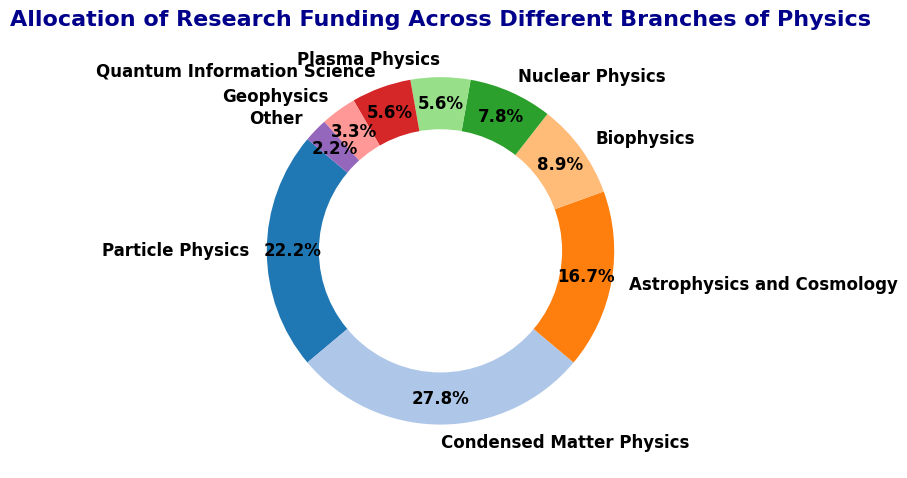Which branch of physics has the largest allocation of funding? Condensed Matter Physics has the highest percentage share of 25%.
Answer: Condensed Matter Physics Which two fields have the smallest percentage of the funding allocation? Geophysics and "Other" have the smallest shares with 3% and 2% respectively.
Answer: Geophysics and Other What is the combined funding allocation for Particle Physics and Plasma Physics? Adding their percentages, Particle Physics has 20% and Plasma Physics has 5%. Thus, 20% + 5% = 25%.
Answer: 25% How much more funding does Astrophysics and Cosmology receive compared to Biophysics? Astrophysics and Cosmology receives 15%, while Biophysics gets 8%. The difference is 15% - 8% = 7%.
Answer: 7% Is the funding for Nuclear Physics greater than or equal to the funding for Quantum Information Science? Both branches have 7% and 5% respectively. Therefore, funding for Nuclear Physics is greater.
Answer: Yes Which branches of physics receive more combined funding: Plasma Physics and Quantum Information Science, or Biophysics? Plasma Physics and Quantum Information Science receive 5% each, totaling 10%. Biophysics gets 8%. Therefore, 10% > 8%.
Answer: Plasma and Quantum Information Science How many fields have their funding share less than 10%? Biophysics (8%), Nuclear Physics (7%), Plasma Physics (5%), Quantum Information (5%), Geophysics (3%), and Other (2%) each have less than 10%. That's 6 fields.
Answer: 6 What is the average funding percentage for Particle Physics, Condensed Matter Physics, and Astrophysics and Cosmology? Their total percentages are 20% + 25% + 15% = 60%. There are 3 fields, so the average is 60% / 3 = 20%.
Answer: 20% If we combine the funding for fields ranked third and fourth in allocation, what is the result? Astrophysics and Cosmology (15%) and Biophysics (8%) are third and fourth respectively. The sum is 15% + 8% = 23%.
Answer: 23% Which branch of physics has a slice colored closest to cyan in the ring chart? Based on the default 'tab20' color cycle, the slice for Quantum Information Science is closest to cyan.
Answer: Quantum Information Science 